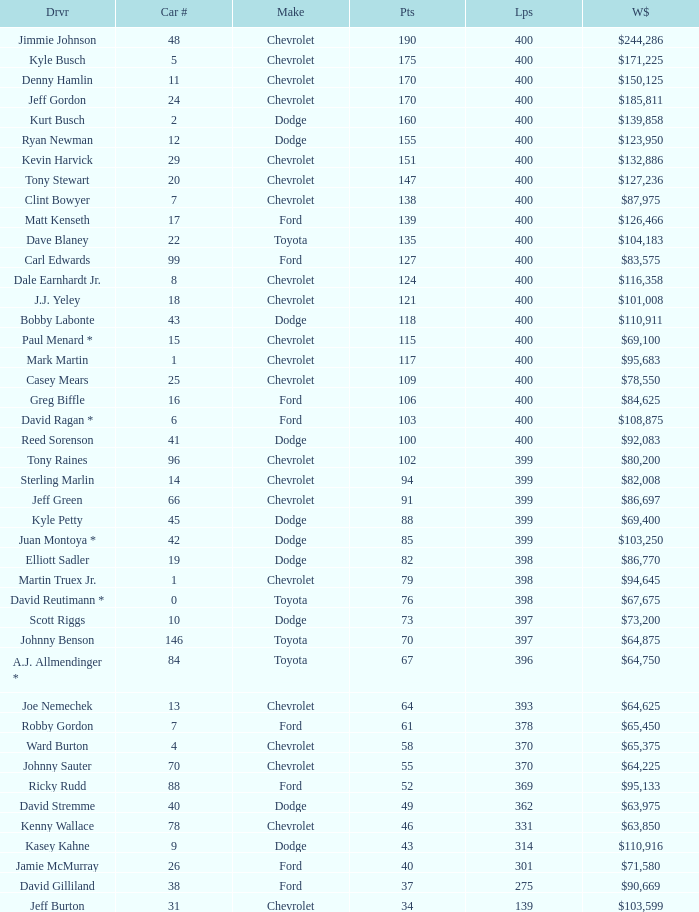What is the brand of car 31? Chevrolet. 